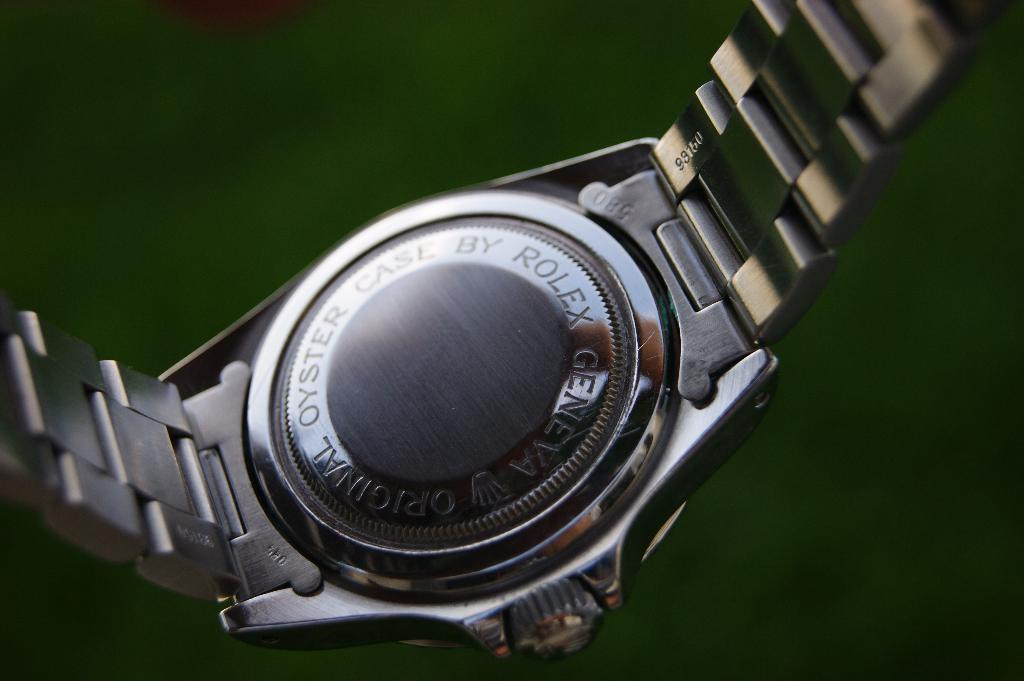<image>
Describe the image concisely. the back of a rolex geneva original oyster case 